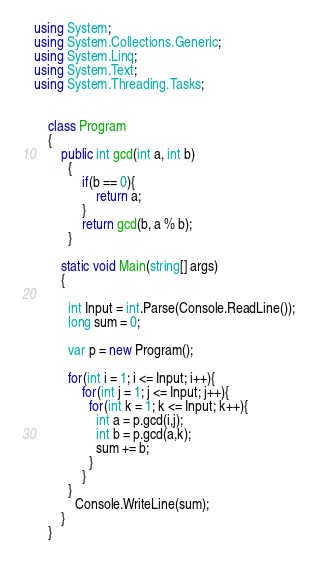<code> <loc_0><loc_0><loc_500><loc_500><_C#_>using System;
using System.Collections.Generic;
using System.Linq;
using System.Text;
using System.Threading.Tasks;


    class Program
    {
        public int gcd(int a, int b)
          {
              if(b == 0){
                  return a;
              }
              return gcd(b, a % b);
          }
        
        static void Main(string[] args)
        {
          
          int Input = int.Parse(Console.ReadLine());
          long sum = 0;
          
          var p = new Program();
          
          for(int i = 1; i <= Input; i++){
              for(int j = 1; j <= Input; j++){
                for(int k = 1; k <= Input; k++){
                  int a = p.gcd(i,j);
                  int b = p.gcd(a,k);
                  sum += b;
                }
              }
          }
            Console.WriteLine(sum);
        }
    }

</code> 